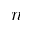<formula> <loc_0><loc_0><loc_500><loc_500>n</formula> 